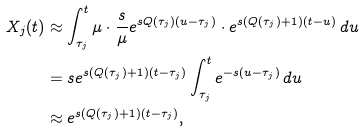<formula> <loc_0><loc_0><loc_500><loc_500>X _ { j } ( t ) & \approx \int _ { \tau _ { j } } ^ { t } \mu \cdot \frac { s } { \mu } e ^ { s Q ( \tau _ { j } ) ( u - \tau _ { j } ) } \cdot e ^ { s ( Q ( \tau _ { j } ) + 1 ) ( t - u ) } \, d u \\ & = s e ^ { s ( Q ( \tau _ { j } ) + 1 ) ( t - \tau _ { j } ) } \int _ { \tau _ { j } } ^ { t } e ^ { - s ( u - \tau _ { j } ) } \, d u \\ & \approx e ^ { s ( Q ( \tau _ { j } ) + 1 ) ( t - \tau _ { j } ) } ,</formula> 